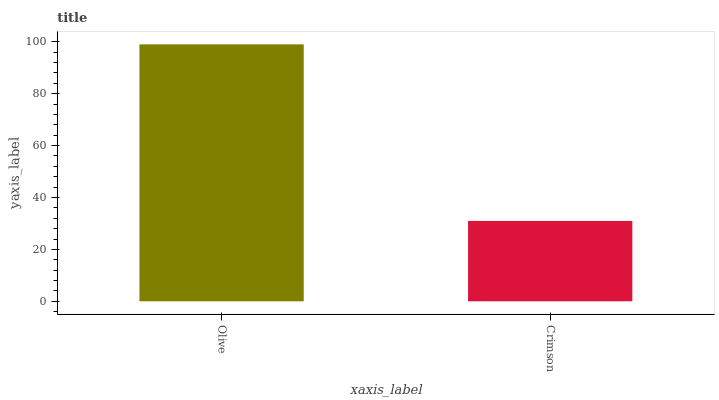Is Crimson the minimum?
Answer yes or no. Yes. Is Olive the maximum?
Answer yes or no. Yes. Is Crimson the maximum?
Answer yes or no. No. Is Olive greater than Crimson?
Answer yes or no. Yes. Is Crimson less than Olive?
Answer yes or no. Yes. Is Crimson greater than Olive?
Answer yes or no. No. Is Olive less than Crimson?
Answer yes or no. No. Is Olive the high median?
Answer yes or no. Yes. Is Crimson the low median?
Answer yes or no. Yes. Is Crimson the high median?
Answer yes or no. No. Is Olive the low median?
Answer yes or no. No. 